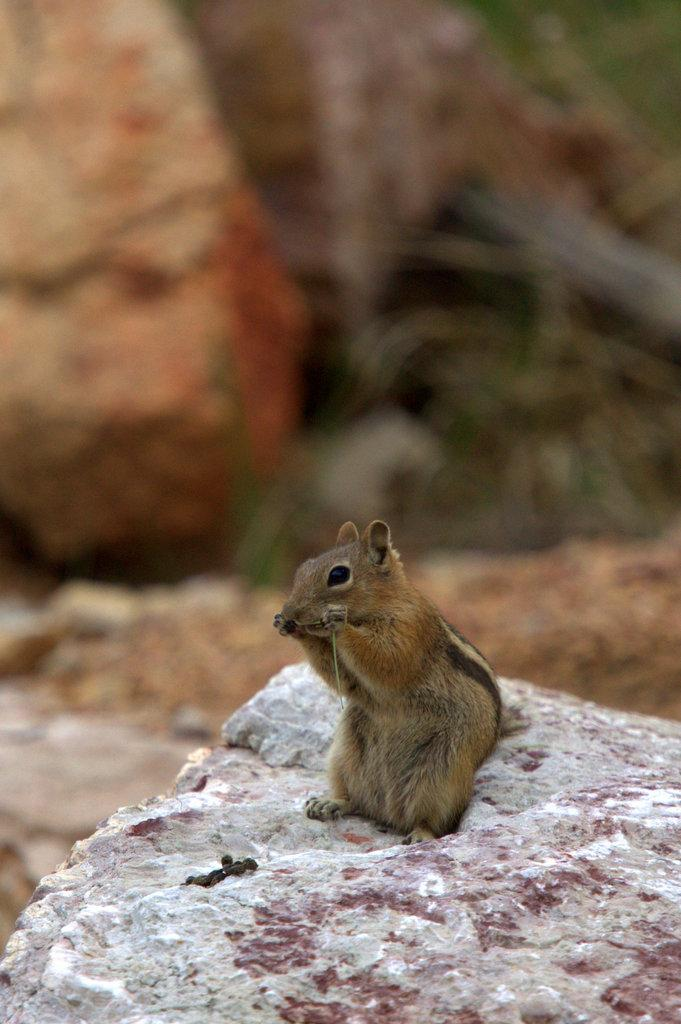What animals can be seen in the image? There are squirrels on a rock surface in the image. What is the primary setting of the image? The primary setting of the image is a rock surface. Are there any other rocks visible in the image? Yes, there are surrounding rocks visible in the image. What type of instrument is being played by the pigs in the image? There are no pigs or instruments present in the image; it features squirrels on a rock surface. 